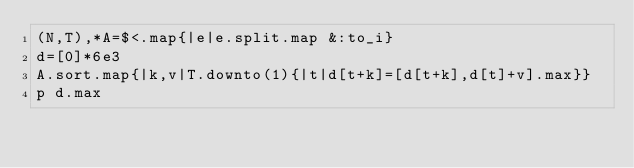Convert code to text. <code><loc_0><loc_0><loc_500><loc_500><_Ruby_>(N,T),*A=$<.map{|e|e.split.map &:to_i}
d=[0]*6e3
A.sort.map{|k,v|T.downto(1){|t|d[t+k]=[d[t+k],d[t]+v].max}}
p d.max</code> 